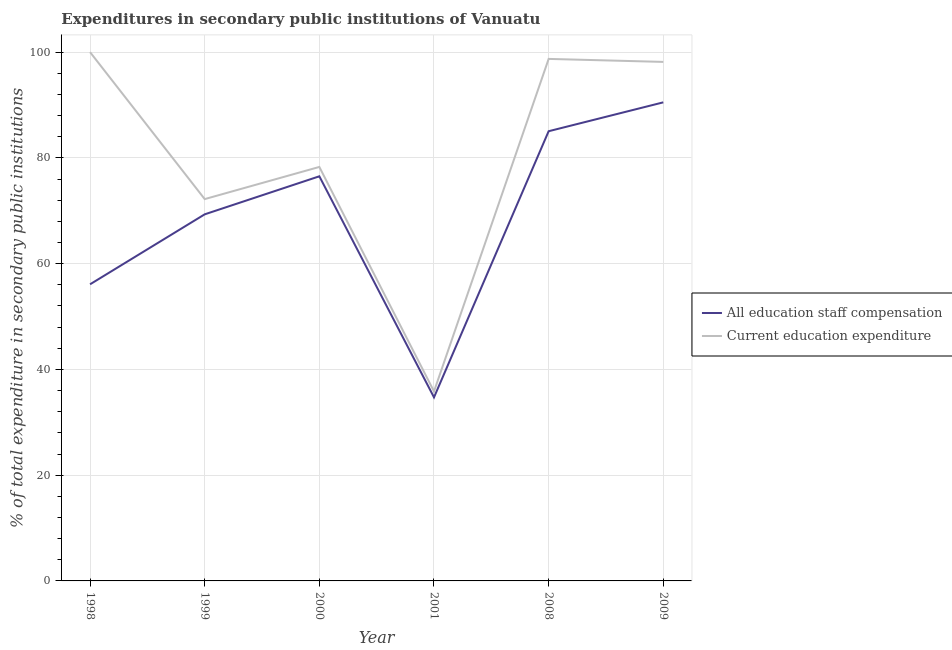Does the line corresponding to expenditure in staff compensation intersect with the line corresponding to expenditure in education?
Your answer should be very brief. No. What is the expenditure in staff compensation in 2000?
Keep it short and to the point. 76.52. Across all years, what is the maximum expenditure in education?
Your answer should be very brief. 100. Across all years, what is the minimum expenditure in staff compensation?
Offer a very short reply. 34.71. What is the total expenditure in staff compensation in the graph?
Offer a very short reply. 412.21. What is the difference between the expenditure in education in 2000 and that in 2008?
Ensure brevity in your answer.  -20.43. What is the difference between the expenditure in education in 2008 and the expenditure in staff compensation in 2001?
Your response must be concise. 64. What is the average expenditure in staff compensation per year?
Your answer should be compact. 68.7. In the year 2009, what is the difference between the expenditure in education and expenditure in staff compensation?
Offer a terse response. 7.65. In how many years, is the expenditure in education greater than 64 %?
Your response must be concise. 5. What is the ratio of the expenditure in staff compensation in 1999 to that in 2009?
Provide a short and direct response. 0.77. Is the expenditure in education in 1999 less than that in 2009?
Provide a succinct answer. Yes. What is the difference between the highest and the second highest expenditure in education?
Your answer should be very brief. 1.28. What is the difference between the highest and the lowest expenditure in staff compensation?
Your response must be concise. 55.79. Is the sum of the expenditure in staff compensation in 1999 and 2008 greater than the maximum expenditure in education across all years?
Offer a terse response. Yes. Is the expenditure in education strictly greater than the expenditure in staff compensation over the years?
Ensure brevity in your answer.  Yes. How many years are there in the graph?
Offer a terse response. 6. Does the graph contain grids?
Give a very brief answer. Yes. What is the title of the graph?
Provide a short and direct response. Expenditures in secondary public institutions of Vanuatu. What is the label or title of the Y-axis?
Provide a short and direct response. % of total expenditure in secondary public institutions. What is the % of total expenditure in secondary public institutions of All education staff compensation in 1998?
Ensure brevity in your answer.  56.09. What is the % of total expenditure in secondary public institutions in Current education expenditure in 1998?
Give a very brief answer. 100. What is the % of total expenditure in secondary public institutions of All education staff compensation in 1999?
Provide a short and direct response. 69.33. What is the % of total expenditure in secondary public institutions of Current education expenditure in 1999?
Your answer should be very brief. 72.21. What is the % of total expenditure in secondary public institutions of All education staff compensation in 2000?
Offer a very short reply. 76.52. What is the % of total expenditure in secondary public institutions of Current education expenditure in 2000?
Offer a very short reply. 78.29. What is the % of total expenditure in secondary public institutions of All education staff compensation in 2001?
Provide a short and direct response. 34.71. What is the % of total expenditure in secondary public institutions of Current education expenditure in 2001?
Make the answer very short. 35.83. What is the % of total expenditure in secondary public institutions of All education staff compensation in 2008?
Offer a terse response. 85.04. What is the % of total expenditure in secondary public institutions of Current education expenditure in 2008?
Ensure brevity in your answer.  98.72. What is the % of total expenditure in secondary public institutions in All education staff compensation in 2009?
Your answer should be compact. 90.51. What is the % of total expenditure in secondary public institutions of Current education expenditure in 2009?
Your answer should be compact. 98.15. Across all years, what is the maximum % of total expenditure in secondary public institutions in All education staff compensation?
Offer a terse response. 90.51. Across all years, what is the minimum % of total expenditure in secondary public institutions of All education staff compensation?
Your answer should be compact. 34.71. Across all years, what is the minimum % of total expenditure in secondary public institutions of Current education expenditure?
Make the answer very short. 35.83. What is the total % of total expenditure in secondary public institutions in All education staff compensation in the graph?
Make the answer very short. 412.2. What is the total % of total expenditure in secondary public institutions of Current education expenditure in the graph?
Give a very brief answer. 483.2. What is the difference between the % of total expenditure in secondary public institutions in All education staff compensation in 1998 and that in 1999?
Provide a short and direct response. -13.23. What is the difference between the % of total expenditure in secondary public institutions of Current education expenditure in 1998 and that in 1999?
Your response must be concise. 27.79. What is the difference between the % of total expenditure in secondary public institutions of All education staff compensation in 1998 and that in 2000?
Provide a short and direct response. -20.43. What is the difference between the % of total expenditure in secondary public institutions in Current education expenditure in 1998 and that in 2000?
Give a very brief answer. 21.71. What is the difference between the % of total expenditure in secondary public institutions of All education staff compensation in 1998 and that in 2001?
Keep it short and to the point. 21.38. What is the difference between the % of total expenditure in secondary public institutions in Current education expenditure in 1998 and that in 2001?
Your answer should be very brief. 64.17. What is the difference between the % of total expenditure in secondary public institutions of All education staff compensation in 1998 and that in 2008?
Ensure brevity in your answer.  -28.95. What is the difference between the % of total expenditure in secondary public institutions of Current education expenditure in 1998 and that in 2008?
Your response must be concise. 1.28. What is the difference between the % of total expenditure in secondary public institutions of All education staff compensation in 1998 and that in 2009?
Keep it short and to the point. -34.41. What is the difference between the % of total expenditure in secondary public institutions in Current education expenditure in 1998 and that in 2009?
Offer a very short reply. 1.85. What is the difference between the % of total expenditure in secondary public institutions of All education staff compensation in 1999 and that in 2000?
Your answer should be compact. -7.19. What is the difference between the % of total expenditure in secondary public institutions of Current education expenditure in 1999 and that in 2000?
Give a very brief answer. -6.08. What is the difference between the % of total expenditure in secondary public institutions of All education staff compensation in 1999 and that in 2001?
Provide a short and direct response. 34.61. What is the difference between the % of total expenditure in secondary public institutions in Current education expenditure in 1999 and that in 2001?
Your answer should be compact. 36.37. What is the difference between the % of total expenditure in secondary public institutions in All education staff compensation in 1999 and that in 2008?
Provide a succinct answer. -15.72. What is the difference between the % of total expenditure in secondary public institutions in Current education expenditure in 1999 and that in 2008?
Your response must be concise. -26.51. What is the difference between the % of total expenditure in secondary public institutions of All education staff compensation in 1999 and that in 2009?
Offer a terse response. -21.18. What is the difference between the % of total expenditure in secondary public institutions in Current education expenditure in 1999 and that in 2009?
Your response must be concise. -25.95. What is the difference between the % of total expenditure in secondary public institutions in All education staff compensation in 2000 and that in 2001?
Provide a succinct answer. 41.8. What is the difference between the % of total expenditure in secondary public institutions of Current education expenditure in 2000 and that in 2001?
Ensure brevity in your answer.  42.46. What is the difference between the % of total expenditure in secondary public institutions in All education staff compensation in 2000 and that in 2008?
Keep it short and to the point. -8.53. What is the difference between the % of total expenditure in secondary public institutions in Current education expenditure in 2000 and that in 2008?
Provide a short and direct response. -20.43. What is the difference between the % of total expenditure in secondary public institutions in All education staff compensation in 2000 and that in 2009?
Give a very brief answer. -13.99. What is the difference between the % of total expenditure in secondary public institutions in Current education expenditure in 2000 and that in 2009?
Keep it short and to the point. -19.86. What is the difference between the % of total expenditure in secondary public institutions of All education staff compensation in 2001 and that in 2008?
Offer a very short reply. -50.33. What is the difference between the % of total expenditure in secondary public institutions of Current education expenditure in 2001 and that in 2008?
Give a very brief answer. -62.89. What is the difference between the % of total expenditure in secondary public institutions in All education staff compensation in 2001 and that in 2009?
Your answer should be compact. -55.79. What is the difference between the % of total expenditure in secondary public institutions of Current education expenditure in 2001 and that in 2009?
Ensure brevity in your answer.  -62.32. What is the difference between the % of total expenditure in secondary public institutions of All education staff compensation in 2008 and that in 2009?
Keep it short and to the point. -5.46. What is the difference between the % of total expenditure in secondary public institutions of Current education expenditure in 2008 and that in 2009?
Provide a short and direct response. 0.57. What is the difference between the % of total expenditure in secondary public institutions of All education staff compensation in 1998 and the % of total expenditure in secondary public institutions of Current education expenditure in 1999?
Ensure brevity in your answer.  -16.11. What is the difference between the % of total expenditure in secondary public institutions of All education staff compensation in 1998 and the % of total expenditure in secondary public institutions of Current education expenditure in 2000?
Give a very brief answer. -22.2. What is the difference between the % of total expenditure in secondary public institutions of All education staff compensation in 1998 and the % of total expenditure in secondary public institutions of Current education expenditure in 2001?
Your response must be concise. 20.26. What is the difference between the % of total expenditure in secondary public institutions of All education staff compensation in 1998 and the % of total expenditure in secondary public institutions of Current education expenditure in 2008?
Ensure brevity in your answer.  -42.62. What is the difference between the % of total expenditure in secondary public institutions in All education staff compensation in 1998 and the % of total expenditure in secondary public institutions in Current education expenditure in 2009?
Make the answer very short. -42.06. What is the difference between the % of total expenditure in secondary public institutions in All education staff compensation in 1999 and the % of total expenditure in secondary public institutions in Current education expenditure in 2000?
Your answer should be very brief. -8.96. What is the difference between the % of total expenditure in secondary public institutions in All education staff compensation in 1999 and the % of total expenditure in secondary public institutions in Current education expenditure in 2001?
Provide a succinct answer. 33.49. What is the difference between the % of total expenditure in secondary public institutions in All education staff compensation in 1999 and the % of total expenditure in secondary public institutions in Current education expenditure in 2008?
Provide a short and direct response. -29.39. What is the difference between the % of total expenditure in secondary public institutions of All education staff compensation in 1999 and the % of total expenditure in secondary public institutions of Current education expenditure in 2009?
Your answer should be very brief. -28.83. What is the difference between the % of total expenditure in secondary public institutions in All education staff compensation in 2000 and the % of total expenditure in secondary public institutions in Current education expenditure in 2001?
Provide a short and direct response. 40.69. What is the difference between the % of total expenditure in secondary public institutions of All education staff compensation in 2000 and the % of total expenditure in secondary public institutions of Current education expenditure in 2008?
Your answer should be compact. -22.2. What is the difference between the % of total expenditure in secondary public institutions of All education staff compensation in 2000 and the % of total expenditure in secondary public institutions of Current education expenditure in 2009?
Ensure brevity in your answer.  -21.63. What is the difference between the % of total expenditure in secondary public institutions of All education staff compensation in 2001 and the % of total expenditure in secondary public institutions of Current education expenditure in 2008?
Ensure brevity in your answer.  -64. What is the difference between the % of total expenditure in secondary public institutions in All education staff compensation in 2001 and the % of total expenditure in secondary public institutions in Current education expenditure in 2009?
Provide a short and direct response. -63.44. What is the difference between the % of total expenditure in secondary public institutions of All education staff compensation in 2008 and the % of total expenditure in secondary public institutions of Current education expenditure in 2009?
Your response must be concise. -13.11. What is the average % of total expenditure in secondary public institutions in All education staff compensation per year?
Your answer should be compact. 68.7. What is the average % of total expenditure in secondary public institutions of Current education expenditure per year?
Provide a succinct answer. 80.53. In the year 1998, what is the difference between the % of total expenditure in secondary public institutions of All education staff compensation and % of total expenditure in secondary public institutions of Current education expenditure?
Ensure brevity in your answer.  -43.91. In the year 1999, what is the difference between the % of total expenditure in secondary public institutions of All education staff compensation and % of total expenditure in secondary public institutions of Current education expenditure?
Ensure brevity in your answer.  -2.88. In the year 2000, what is the difference between the % of total expenditure in secondary public institutions of All education staff compensation and % of total expenditure in secondary public institutions of Current education expenditure?
Your answer should be compact. -1.77. In the year 2001, what is the difference between the % of total expenditure in secondary public institutions in All education staff compensation and % of total expenditure in secondary public institutions in Current education expenditure?
Offer a very short reply. -1.12. In the year 2008, what is the difference between the % of total expenditure in secondary public institutions of All education staff compensation and % of total expenditure in secondary public institutions of Current education expenditure?
Provide a short and direct response. -13.67. In the year 2009, what is the difference between the % of total expenditure in secondary public institutions of All education staff compensation and % of total expenditure in secondary public institutions of Current education expenditure?
Provide a succinct answer. -7.65. What is the ratio of the % of total expenditure in secondary public institutions in All education staff compensation in 1998 to that in 1999?
Ensure brevity in your answer.  0.81. What is the ratio of the % of total expenditure in secondary public institutions of Current education expenditure in 1998 to that in 1999?
Your answer should be compact. 1.38. What is the ratio of the % of total expenditure in secondary public institutions in All education staff compensation in 1998 to that in 2000?
Your response must be concise. 0.73. What is the ratio of the % of total expenditure in secondary public institutions in Current education expenditure in 1998 to that in 2000?
Your response must be concise. 1.28. What is the ratio of the % of total expenditure in secondary public institutions of All education staff compensation in 1998 to that in 2001?
Your answer should be compact. 1.62. What is the ratio of the % of total expenditure in secondary public institutions of Current education expenditure in 1998 to that in 2001?
Ensure brevity in your answer.  2.79. What is the ratio of the % of total expenditure in secondary public institutions in All education staff compensation in 1998 to that in 2008?
Provide a succinct answer. 0.66. What is the ratio of the % of total expenditure in secondary public institutions in All education staff compensation in 1998 to that in 2009?
Offer a terse response. 0.62. What is the ratio of the % of total expenditure in secondary public institutions in Current education expenditure in 1998 to that in 2009?
Your response must be concise. 1.02. What is the ratio of the % of total expenditure in secondary public institutions of All education staff compensation in 1999 to that in 2000?
Ensure brevity in your answer.  0.91. What is the ratio of the % of total expenditure in secondary public institutions in Current education expenditure in 1999 to that in 2000?
Your answer should be compact. 0.92. What is the ratio of the % of total expenditure in secondary public institutions in All education staff compensation in 1999 to that in 2001?
Offer a terse response. 2. What is the ratio of the % of total expenditure in secondary public institutions of Current education expenditure in 1999 to that in 2001?
Make the answer very short. 2.02. What is the ratio of the % of total expenditure in secondary public institutions of All education staff compensation in 1999 to that in 2008?
Your answer should be compact. 0.82. What is the ratio of the % of total expenditure in secondary public institutions in Current education expenditure in 1999 to that in 2008?
Provide a short and direct response. 0.73. What is the ratio of the % of total expenditure in secondary public institutions of All education staff compensation in 1999 to that in 2009?
Keep it short and to the point. 0.77. What is the ratio of the % of total expenditure in secondary public institutions in Current education expenditure in 1999 to that in 2009?
Your response must be concise. 0.74. What is the ratio of the % of total expenditure in secondary public institutions in All education staff compensation in 2000 to that in 2001?
Keep it short and to the point. 2.2. What is the ratio of the % of total expenditure in secondary public institutions in Current education expenditure in 2000 to that in 2001?
Your answer should be very brief. 2.18. What is the ratio of the % of total expenditure in secondary public institutions of All education staff compensation in 2000 to that in 2008?
Provide a succinct answer. 0.9. What is the ratio of the % of total expenditure in secondary public institutions in Current education expenditure in 2000 to that in 2008?
Give a very brief answer. 0.79. What is the ratio of the % of total expenditure in secondary public institutions of All education staff compensation in 2000 to that in 2009?
Your answer should be very brief. 0.85. What is the ratio of the % of total expenditure in secondary public institutions of Current education expenditure in 2000 to that in 2009?
Ensure brevity in your answer.  0.8. What is the ratio of the % of total expenditure in secondary public institutions of All education staff compensation in 2001 to that in 2008?
Make the answer very short. 0.41. What is the ratio of the % of total expenditure in secondary public institutions in Current education expenditure in 2001 to that in 2008?
Your answer should be very brief. 0.36. What is the ratio of the % of total expenditure in secondary public institutions in All education staff compensation in 2001 to that in 2009?
Offer a terse response. 0.38. What is the ratio of the % of total expenditure in secondary public institutions in Current education expenditure in 2001 to that in 2009?
Provide a succinct answer. 0.37. What is the ratio of the % of total expenditure in secondary public institutions of All education staff compensation in 2008 to that in 2009?
Your response must be concise. 0.94. What is the difference between the highest and the second highest % of total expenditure in secondary public institutions in All education staff compensation?
Ensure brevity in your answer.  5.46. What is the difference between the highest and the second highest % of total expenditure in secondary public institutions in Current education expenditure?
Your response must be concise. 1.28. What is the difference between the highest and the lowest % of total expenditure in secondary public institutions in All education staff compensation?
Provide a succinct answer. 55.79. What is the difference between the highest and the lowest % of total expenditure in secondary public institutions of Current education expenditure?
Your answer should be compact. 64.17. 